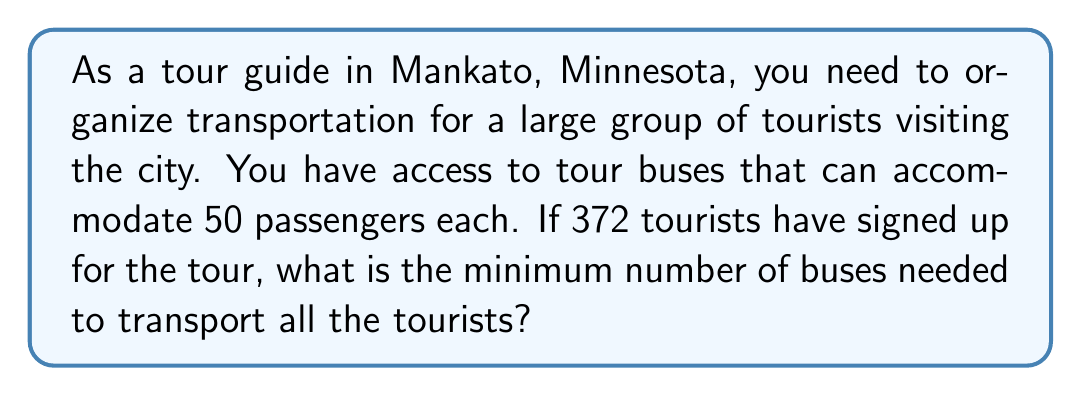Show me your answer to this math problem. To solve this problem, we need to use the ceiling function, which is denoted by $\lceil x \rceil$ in mathematical notation. The ceiling function rounds up a number to the nearest integer.

Let's approach this step-by-step:

1. Define variables:
   Let $n$ be the number of tourists
   Let $c$ be the capacity of each bus
   Let $b$ be the number of buses needed

2. We know that:
   $n = 372$ (number of tourists)
   $c = 50$ (capacity of each bus)

3. To find the number of buses, we divide the number of tourists by the capacity of each bus:
   
   $b = \frac{n}{c}$

4. Substituting the values:
   
   $b = \frac{372}{50} = 7.44$

5. Since we can't have a fractional number of buses, we need to round up to the nearest whole number. This is where the ceiling function comes in:

   $b = \left\lceil\frac{n}{c}\right\rceil = \left\lceil\frac{372}{50}\right\rceil = \lceil 7.44 \rceil = 8$

Therefore, the minimum number of buses needed is 8.

It's worth noting that this solution ensures that all 372 tourists will have a seat, even though the last bus will not be full. The 8 buses will have a total capacity of $8 \times 50 = 400$ seats, which is more than enough for 372 tourists.
Answer: The minimum number of tour buses needed to transport 372 tourists is $\left\lceil\frac{372}{50}\right\rceil = 8$ buses. 